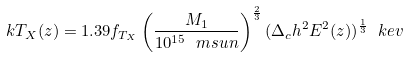<formula> <loc_0><loc_0><loc_500><loc_500>k T _ { X } ( z ) = 1 . 3 9 f _ { T _ { X } } \left ( \frac { M _ { 1 } } { 1 0 ^ { 1 5 } \ m s u n } \right ) ^ { \frac { 2 } { 3 } } ( \Delta _ { c } h ^ { 2 } E ^ { 2 } ( z ) ) ^ { \frac { 1 } { 3 } } \ k e v</formula> 